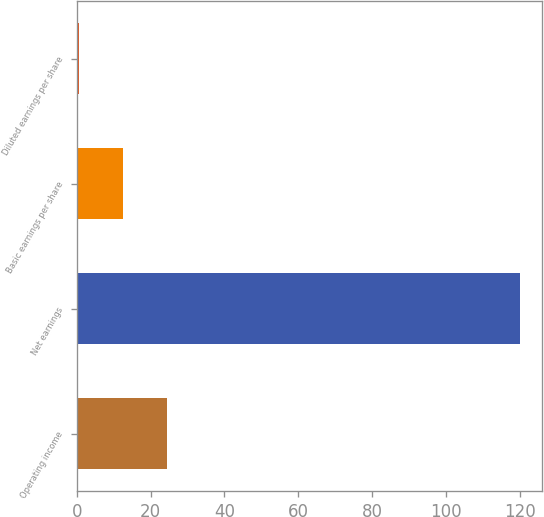<chart> <loc_0><loc_0><loc_500><loc_500><bar_chart><fcel>Operating income<fcel>Net earnings<fcel>Basic earnings per share<fcel>Diluted earnings per share<nl><fcel>24.54<fcel>120<fcel>12.61<fcel>0.68<nl></chart> 